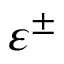Convert formula to latex. <formula><loc_0><loc_0><loc_500><loc_500>\varepsilon ^ { \pm }</formula> 